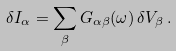<formula> <loc_0><loc_0><loc_500><loc_500>\delta I _ { \alpha } = \sum _ { \beta } G _ { \alpha \beta } ( \omega ) \, \delta V _ { \beta } \, .</formula> 